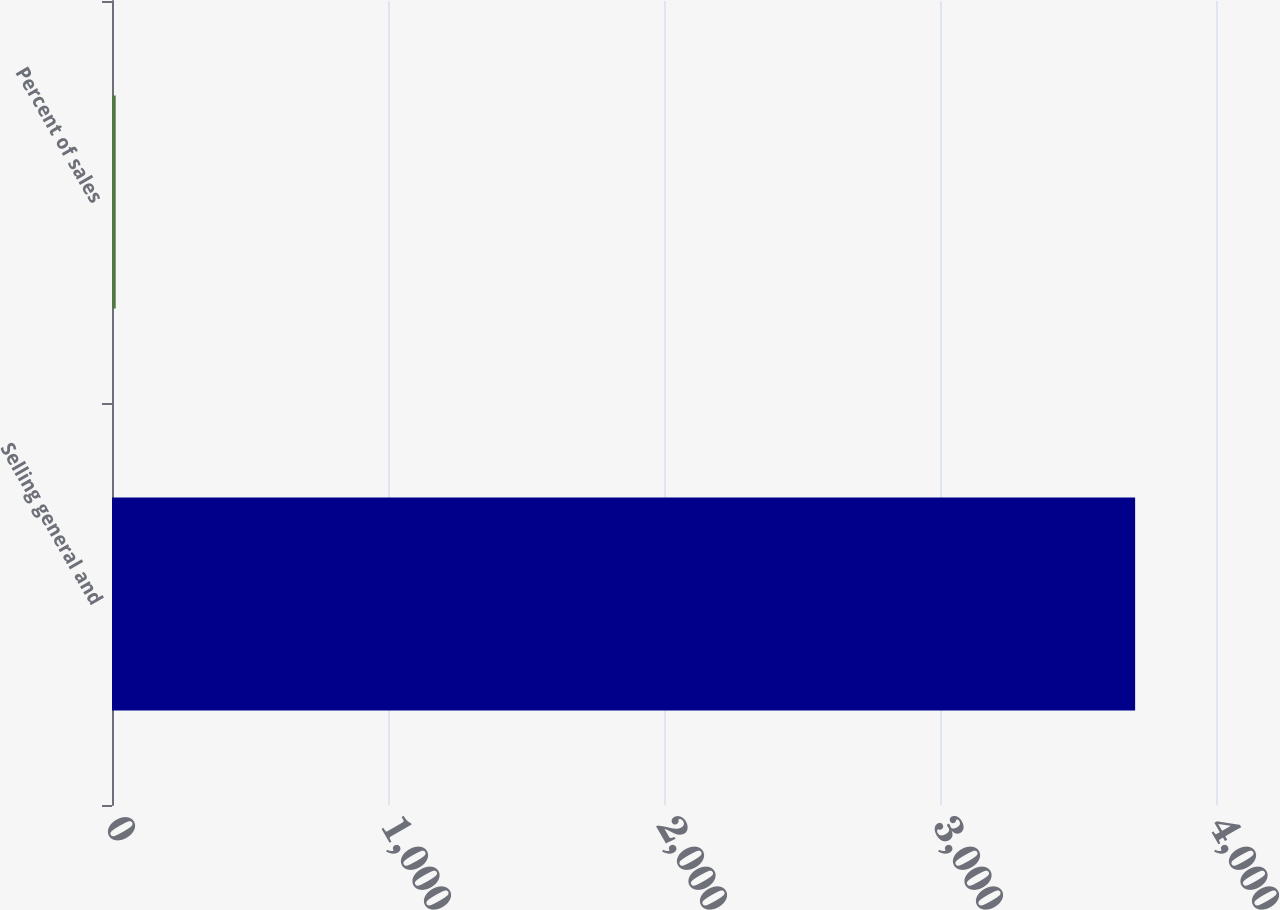<chart> <loc_0><loc_0><loc_500><loc_500><bar_chart><fcel>Selling general and<fcel>Percent of sales<nl><fcel>3707<fcel>13.4<nl></chart> 